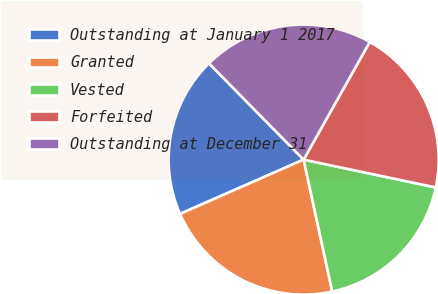Convert chart. <chart><loc_0><loc_0><loc_500><loc_500><pie_chart><fcel>Outstanding at January 1 2017<fcel>Granted<fcel>Vested<fcel>Forfeited<fcel>Outstanding at December 31<nl><fcel>19.22%<fcel>21.81%<fcel>18.3%<fcel>20.16%<fcel>20.51%<nl></chart> 